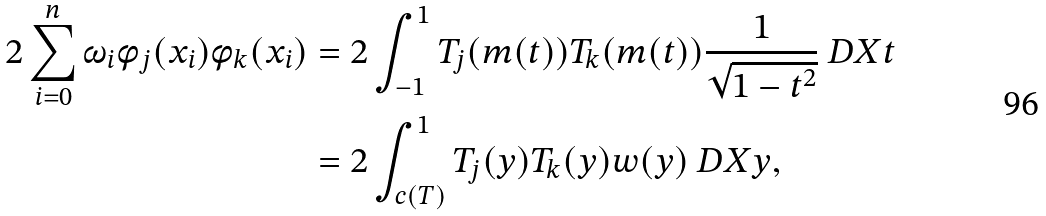<formula> <loc_0><loc_0><loc_500><loc_500>2 \sum ^ { n } _ { i = 0 } \omega _ { i } \phi _ { j } ( x _ { i } ) \phi _ { k } ( x _ { i } ) & = 2 \int ^ { 1 } _ { - 1 } T _ { j } ( m ( t ) ) T _ { k } ( m ( t ) ) \frac { 1 } { \sqrt { 1 - t ^ { 2 } } } \ D X { t } \\ & = 2 \int ^ { 1 } _ { c ( T ) } T _ { j } ( y ) T _ { k } ( y ) w ( y ) \ D X { y } ,</formula> 